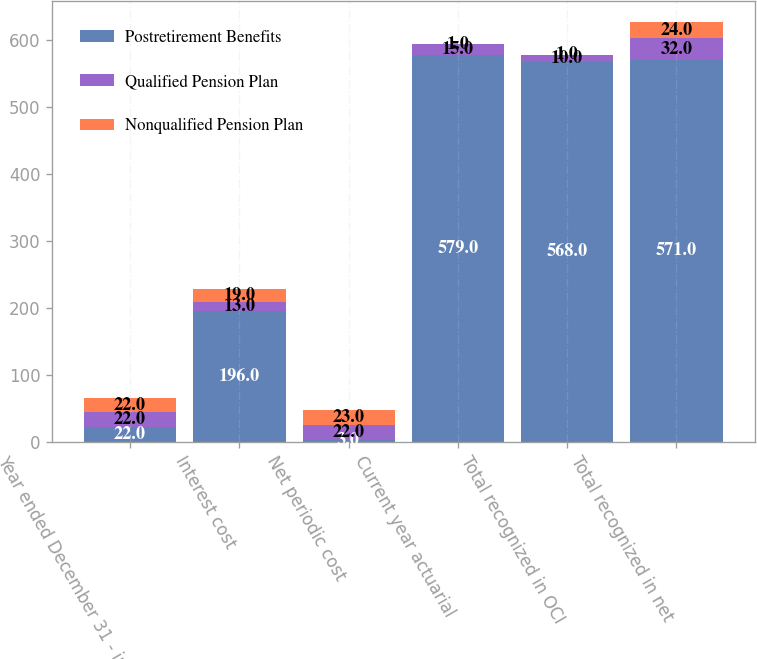<chart> <loc_0><loc_0><loc_500><loc_500><stacked_bar_chart><ecel><fcel>Year ended December 31 - in<fcel>Interest cost<fcel>Net periodic cost<fcel>Current year actuarial<fcel>Total recognized in OCI<fcel>Total recognized in net<nl><fcel>Postretirement Benefits<fcel>22<fcel>196<fcel>3<fcel>579<fcel>568<fcel>571<nl><fcel>Qualified Pension Plan<fcel>22<fcel>13<fcel>22<fcel>15<fcel>10<fcel>32<nl><fcel>Nonqualified Pension Plan<fcel>22<fcel>19<fcel>23<fcel>1<fcel>1<fcel>24<nl></chart> 